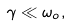Convert formula to latex. <formula><loc_0><loc_0><loc_500><loc_500>\gamma \ll \omega _ { o } ,</formula> 